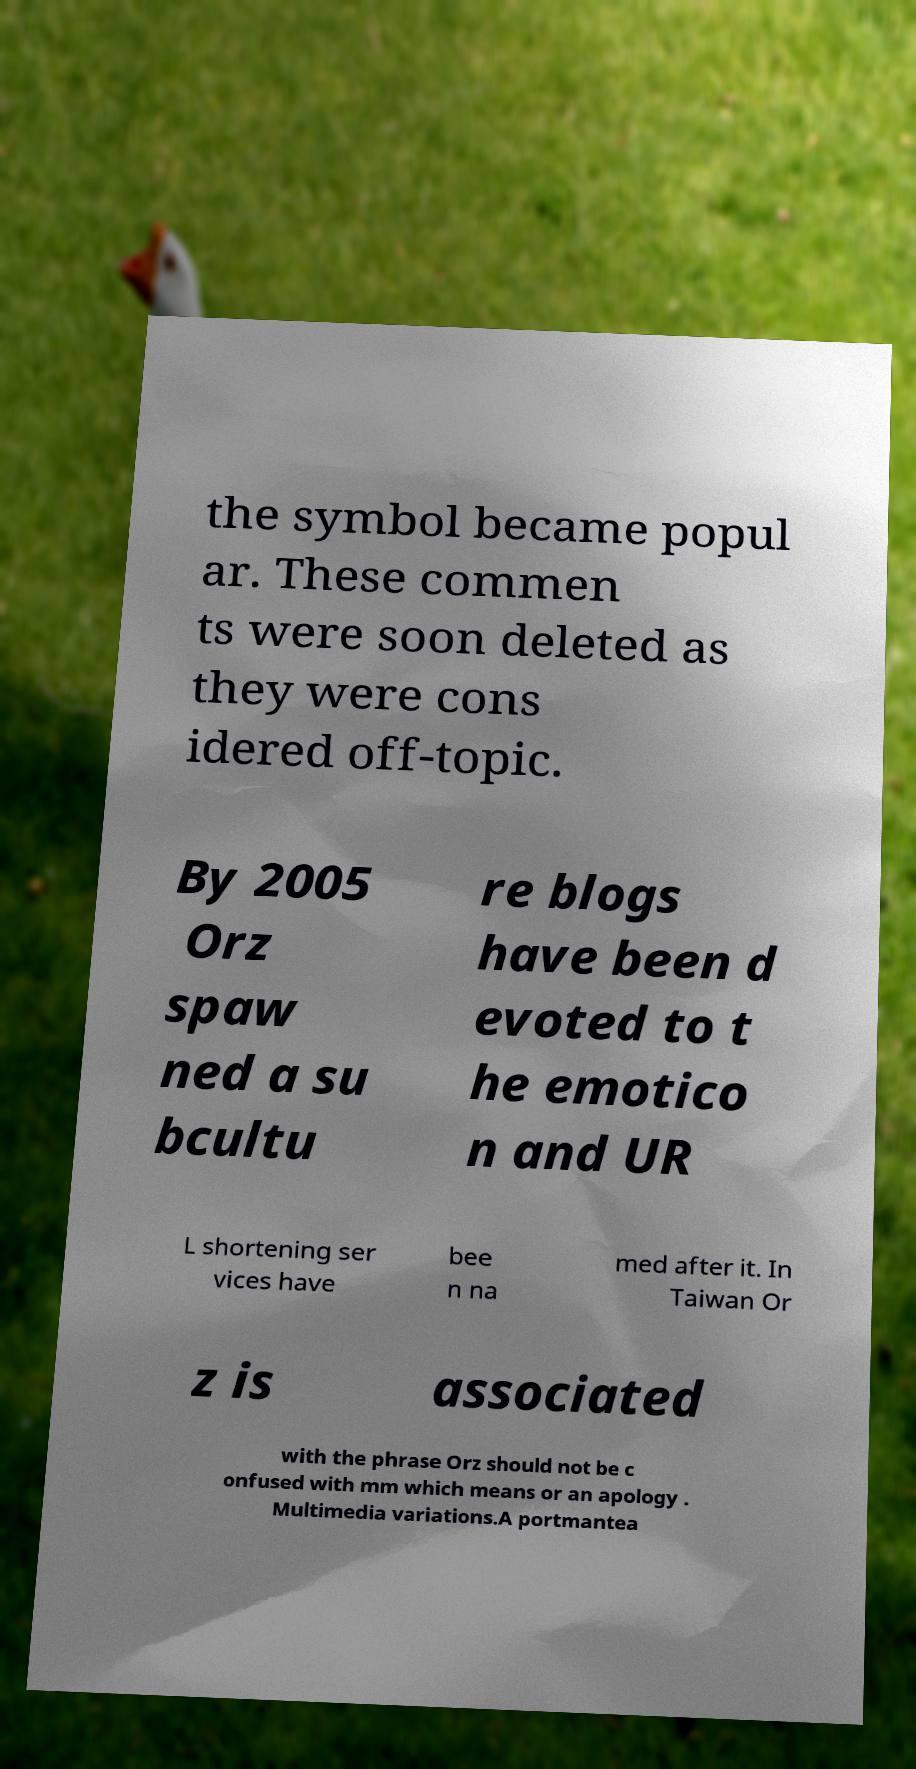Please identify and transcribe the text found in this image. the symbol became popul ar. These commen ts were soon deleted as they were cons idered off-topic. By 2005 Orz spaw ned a su bcultu re blogs have been d evoted to t he emotico n and UR L shortening ser vices have bee n na med after it. In Taiwan Or z is associated with the phrase Orz should not be c onfused with mm which means or an apology . Multimedia variations.A portmantea 